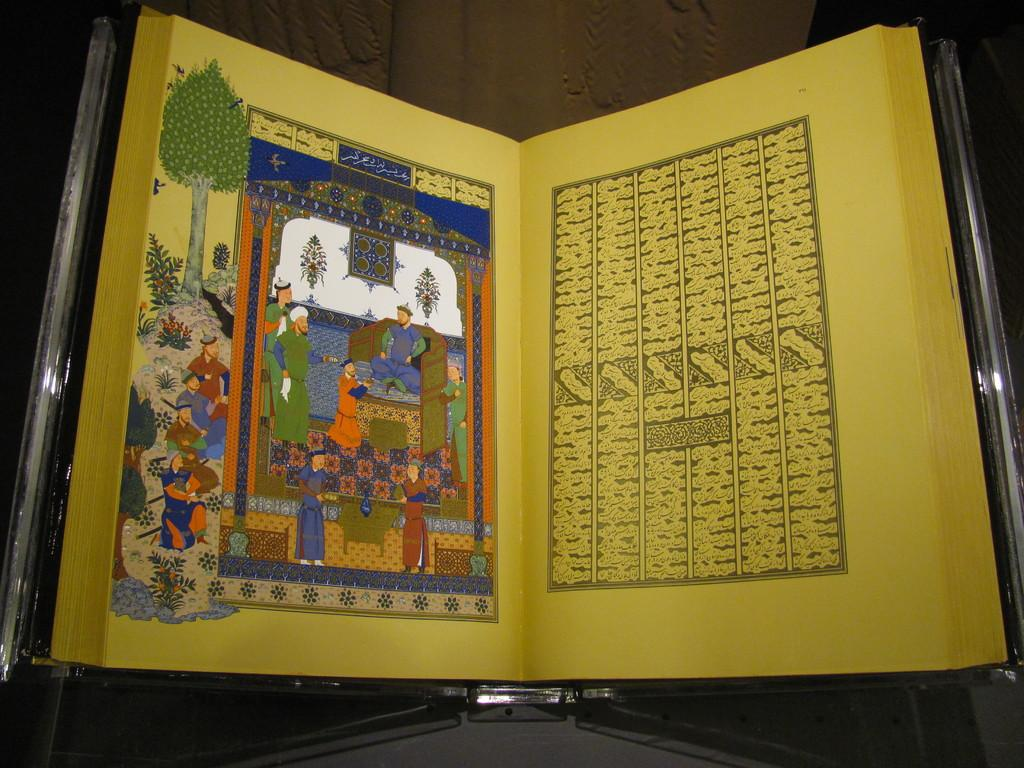What is present in the image? There is a book in the image. What type of content does the book contain? The book contains text and drawings. What type of glass is used to create the drawings in the book? There is no mention of glass being used to create the drawings in the book. The drawings are likely created using traditional drawing materials, such as pencils or pens. 